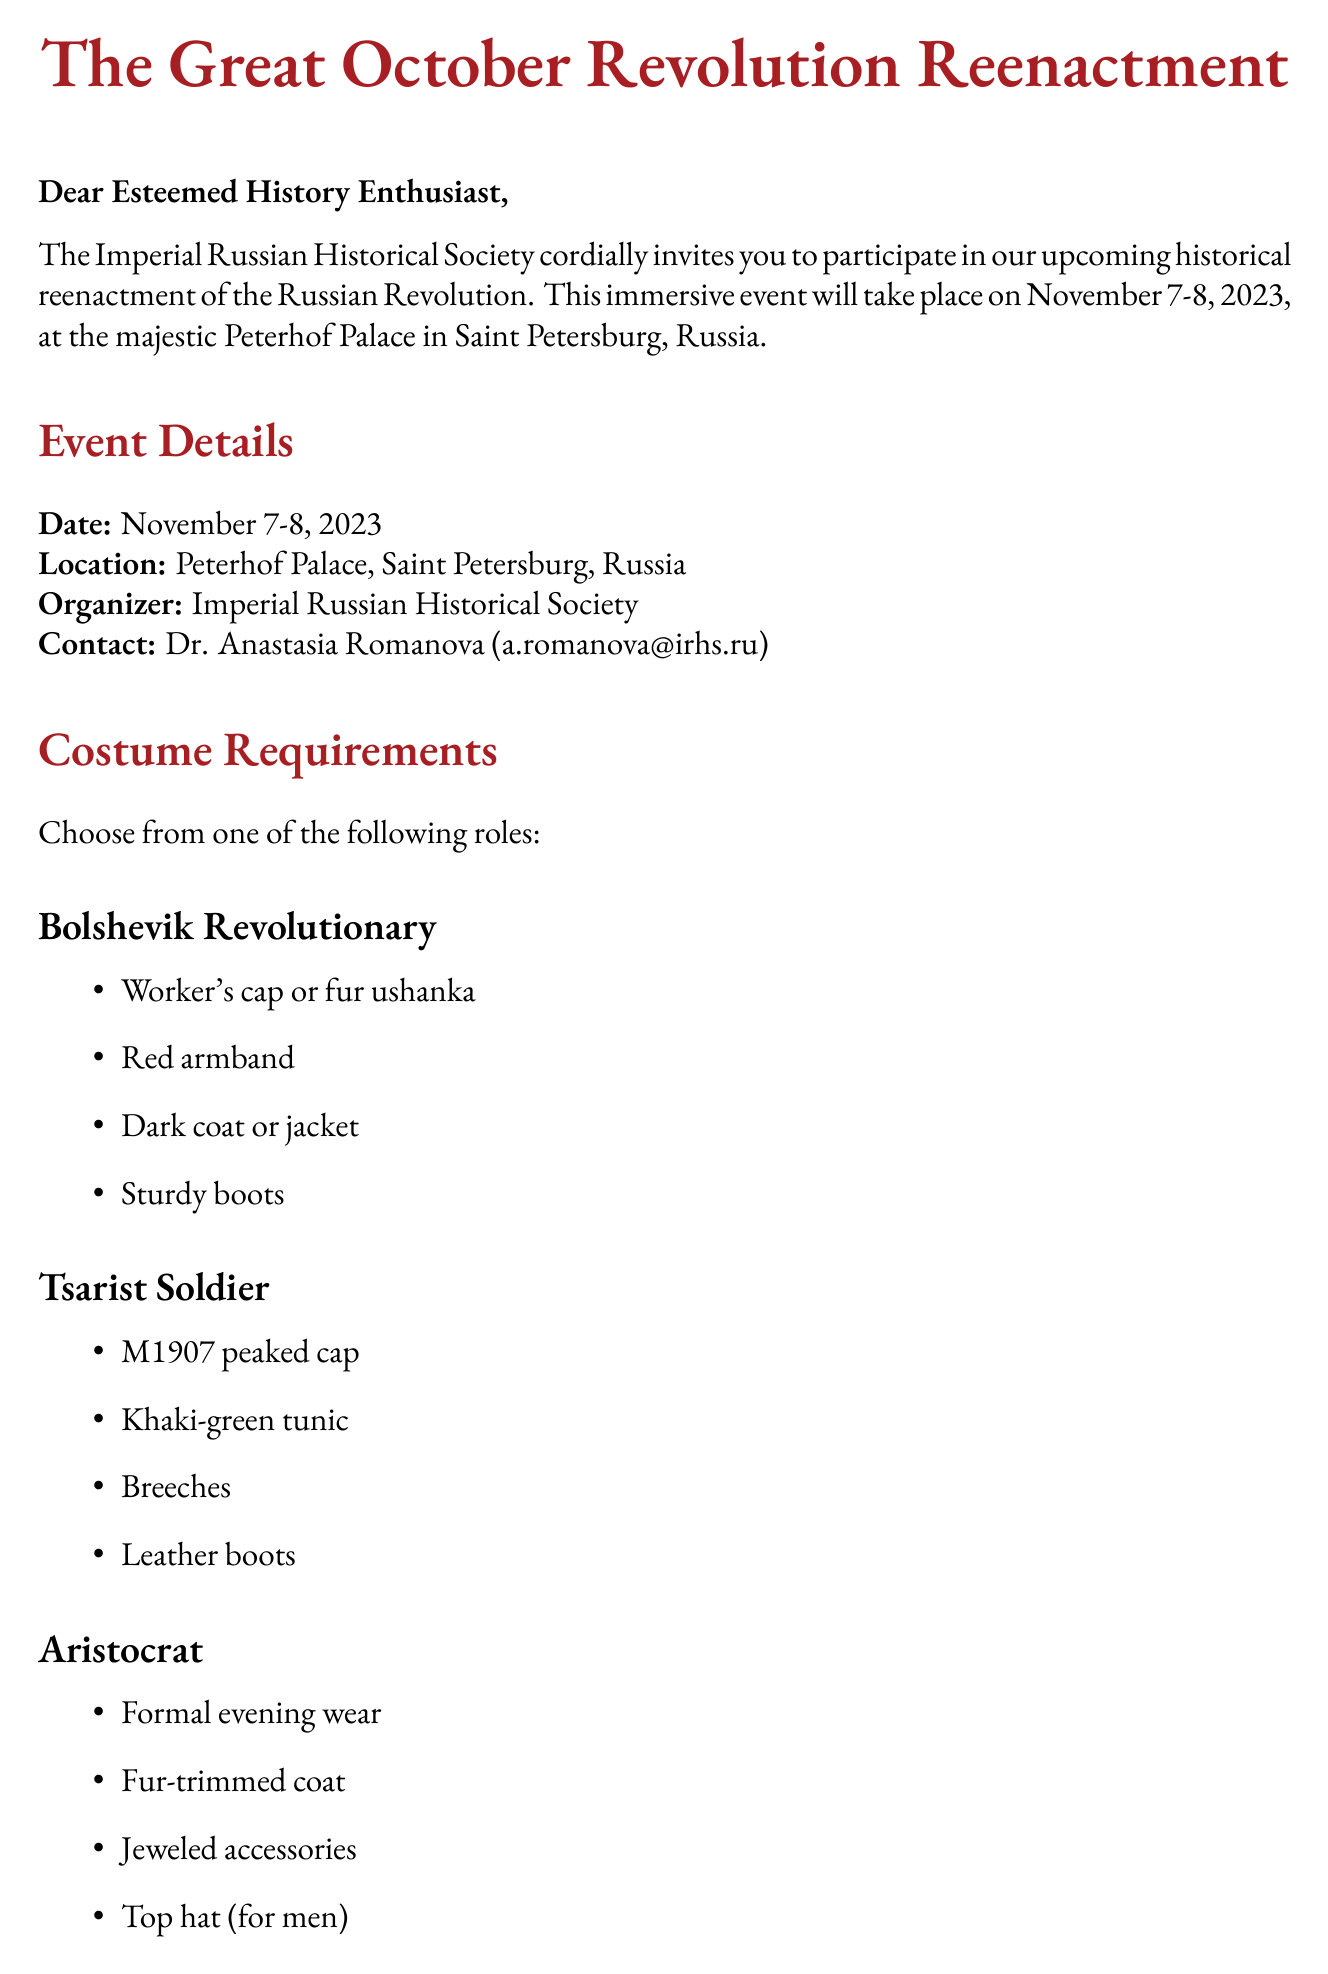what are the event dates? The event dates are explicitly mentioned in the document as November 7-8, 2023.
Answer: November 7-8, 2023 who is the contact person for the event? The document specifies Dr. Anastasia Romanova as the contact person for the event.
Answer: Dr. Anastasia Romanova which hotel is recommended for accommodation? The document provides a specific hotel name for accommodation, which is Hotel Astoria.
Answer: Hotel Astoria what is one of the costume requirements for a Bolshevik Revolutionary? The document lists multiple items but one specific item is a red armband as part of the costume for a Bolshevik Revolutionary.
Answer: Red armband what time does registration start on November 7? The document states that registration and costume check begin at 09:00 on November 7.
Answer: 09:00 how many events are scheduled for November 8? The schedule outlines four activities planned for November 8, requiring reasoning over the listed events in the document.
Answer: Four what should participants bring for a period-accurate experience? The document mentions participants should use period-appropriate cameras for photography, requiring integration of details.
Answer: Period-appropriate cameras what type of dinner is offered on November 7? The document describes the dinner event on November 7 as an "authentic 1917 dinner experience."
Answer: Authentic 1917 dinner experience 